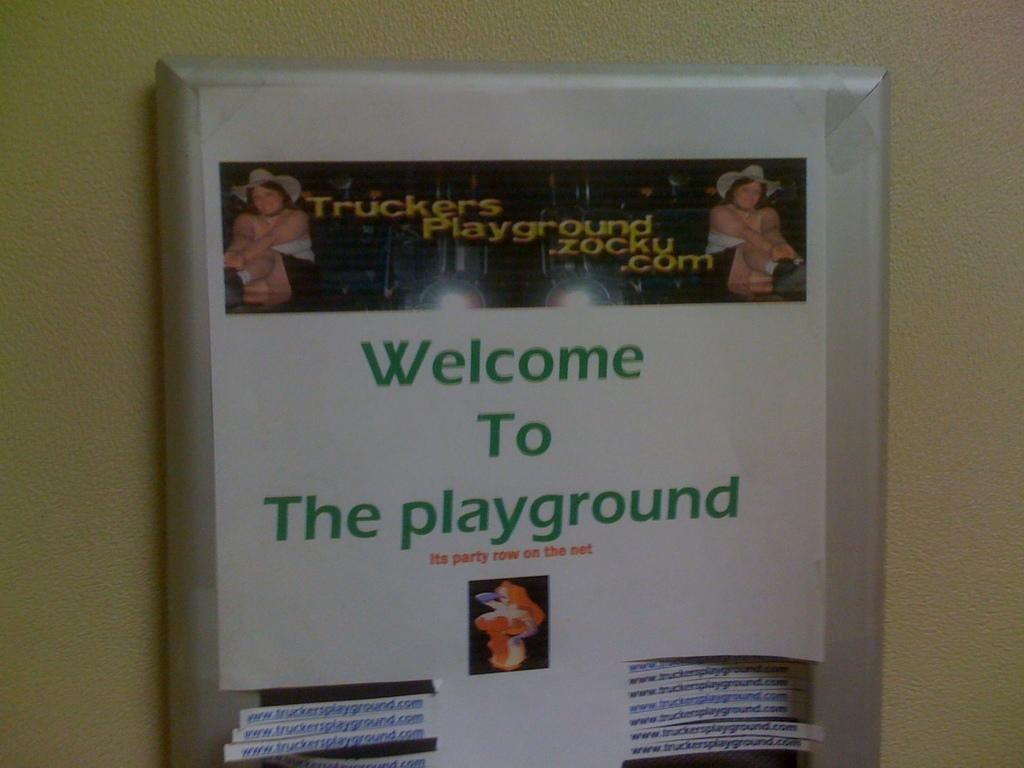<image>
Present a compact description of the photo's key features. poster for website truckersplayground.zocku.com and message welcome to the playground 